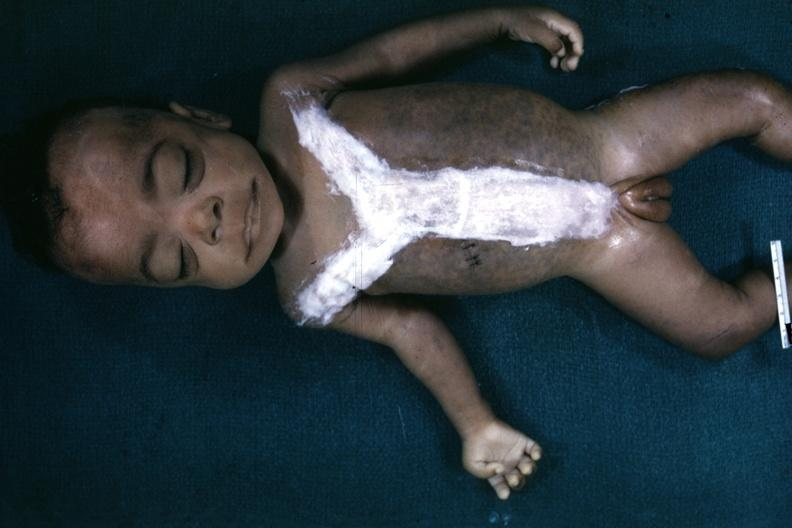what is opened to show simian crease quite good example?
Answer the question using a single word or phrase. Whole body after autopsy with covered incision very representation of mongoloid facies and one hand 